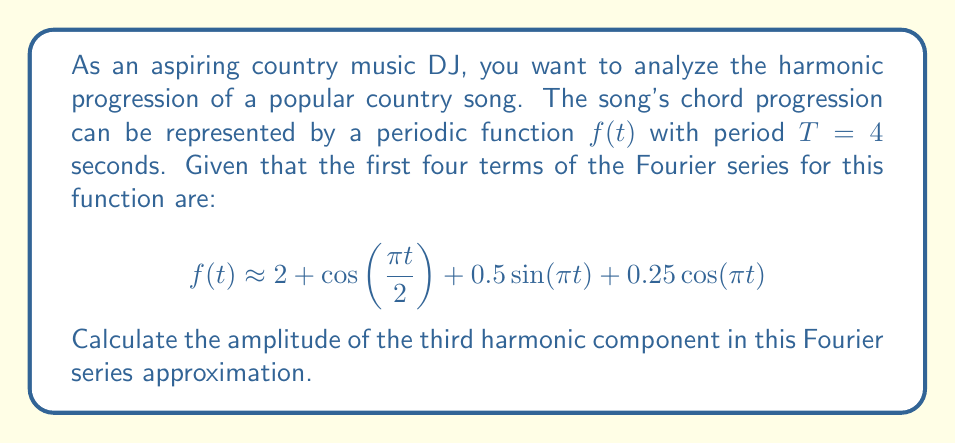Help me with this question. To solve this problem, let's follow these steps:

1) Recall that the general form of a Fourier series is:

   $$ f(t) = a_0 + \sum_{n=1}^{\infty} [a_n \cos(\frac{2\pi n t}{T}) + b_n \sin(\frac{2\pi n t}{T})] $$

2) In our case, $T=4$ seconds, so $\frac{2\pi}{T} = \frac{\pi}{2}$

3) Comparing our given function to the general form:

   $a_0 = 2$
   $a_1 \cos(\frac{\pi t}{2}) = \cos(\frac{\pi t}{2})$, so $a_1 = 1$
   $b_1 \sin(\frac{\pi t}{2}) = 0$, so $b_1 = 0$
   $a_2 \cos(\pi t) = 0.25\cos(\pi t)$, so $a_2 = 0.25$
   $b_2 \sin(\pi t) = 0.5\sin(\pi t)$, so $b_2 = 0.5$

4) The third harmonic corresponds to $n=3$ in the Fourier series. However, we don't have terms for $n=3$ in our given approximation.

5) The amplitude of a harmonic is given by $\sqrt{a_n^2 + b_n^2}$

6) Since we don't have $a_3$ or $b_3$, they are effectively zero in this approximation.

7) Therefore, the amplitude of the third harmonic is:

   $\sqrt{a_3^2 + b_3^2} = \sqrt{0^2 + 0^2} = 0$
Answer: 0 